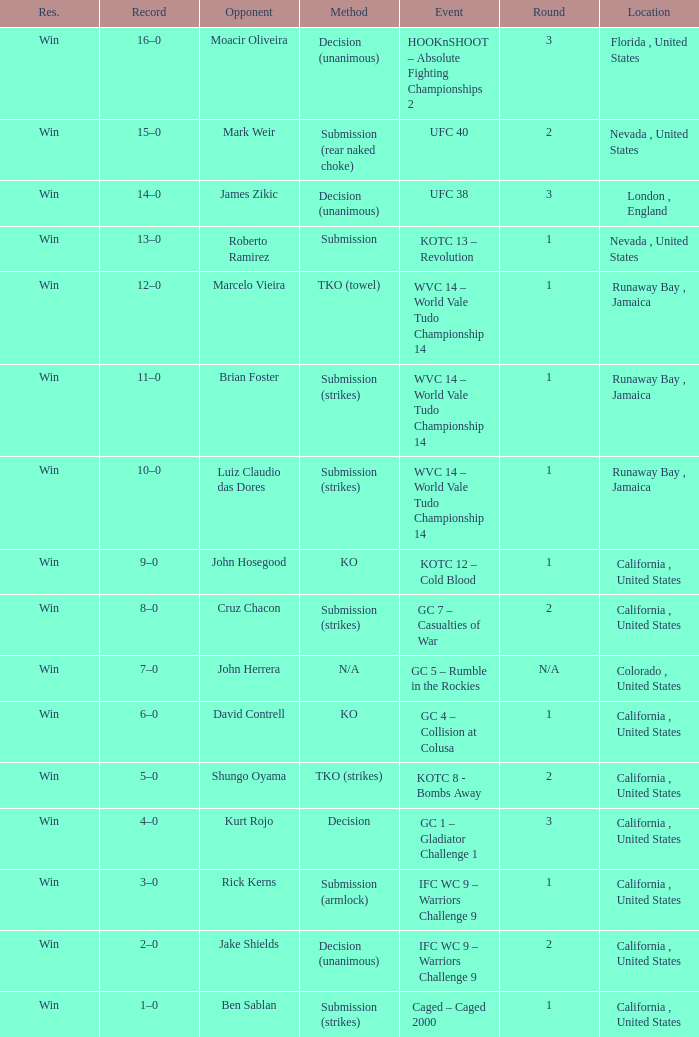Could you parse the entire table as a dict? {'header': ['Res.', 'Record', 'Opponent', 'Method', 'Event', 'Round', 'Location'], 'rows': [['Win', '16–0', 'Moacir Oliveira', 'Decision (unanimous)', 'HOOKnSHOOT – Absolute Fighting Championships 2', '3', 'Florida , United States'], ['Win', '15–0', 'Mark Weir', 'Submission (rear naked choke)', 'UFC 40', '2', 'Nevada , United States'], ['Win', '14–0', 'James Zikic', 'Decision (unanimous)', 'UFC 38', '3', 'London , England'], ['Win', '13–0', 'Roberto Ramirez', 'Submission', 'KOTC 13 – Revolution', '1', 'Nevada , United States'], ['Win', '12–0', 'Marcelo Vieira', 'TKO (towel)', 'WVC 14 – World Vale Tudo Championship 14', '1', 'Runaway Bay , Jamaica'], ['Win', '11–0', 'Brian Foster', 'Submission (strikes)', 'WVC 14 – World Vale Tudo Championship 14', '1', 'Runaway Bay , Jamaica'], ['Win', '10–0', 'Luiz Claudio das Dores', 'Submission (strikes)', 'WVC 14 – World Vale Tudo Championship 14', '1', 'Runaway Bay , Jamaica'], ['Win', '9–0', 'John Hosegood', 'KO', 'KOTC 12 – Cold Blood', '1', 'California , United States'], ['Win', '8–0', 'Cruz Chacon', 'Submission (strikes)', 'GC 7 – Casualties of War', '2', 'California , United States'], ['Win', '7–0', 'John Herrera', 'N/A', 'GC 5 – Rumble in the Rockies', 'N/A', 'Colorado , United States'], ['Win', '6–0', 'David Contrell', 'KO', 'GC 4 – Collision at Colusa', '1', 'California , United States'], ['Win', '5–0', 'Shungo Oyama', 'TKO (strikes)', 'KOTC 8 - Bombs Away', '2', 'California , United States'], ['Win', '4–0', 'Kurt Rojo', 'Decision', 'GC 1 – Gladiator Challenge 1', '3', 'California , United States'], ['Win', '3–0', 'Rick Kerns', 'Submission (armlock)', 'IFC WC 9 – Warriors Challenge 9', '1', 'California , United States'], ['Win', '2–0', 'Jake Shields', 'Decision (unanimous)', 'IFC WC 9 – Warriors Challenge 9', '2', 'California , United States'], ['Win', '1–0', 'Ben Sablan', 'Submission (strikes)', 'Caged – Caged 2000', '1', 'California , United States']]} What was the venue of the fight that only lasted one round against luiz claudio das dores? Runaway Bay , Jamaica. 